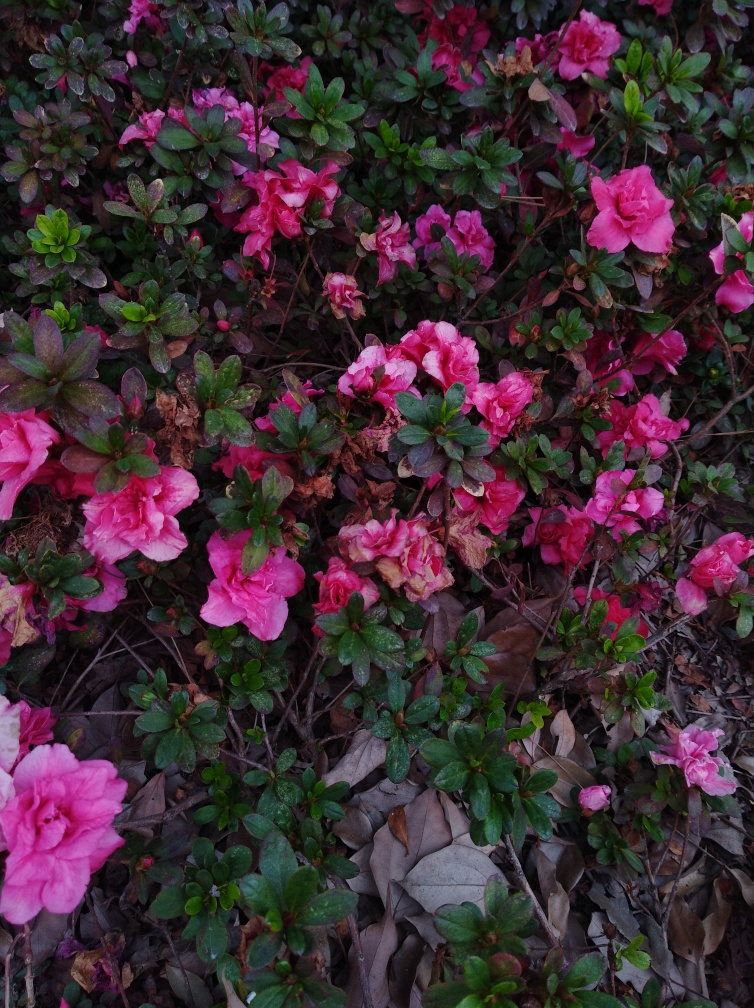Is the quality of the image good? The quality of the image is quite clear, showcasing the flowers and leaves with good detail and color balance; however, there may be room for improvement in terms of brightness and contrast to make the image even more vibrant. 